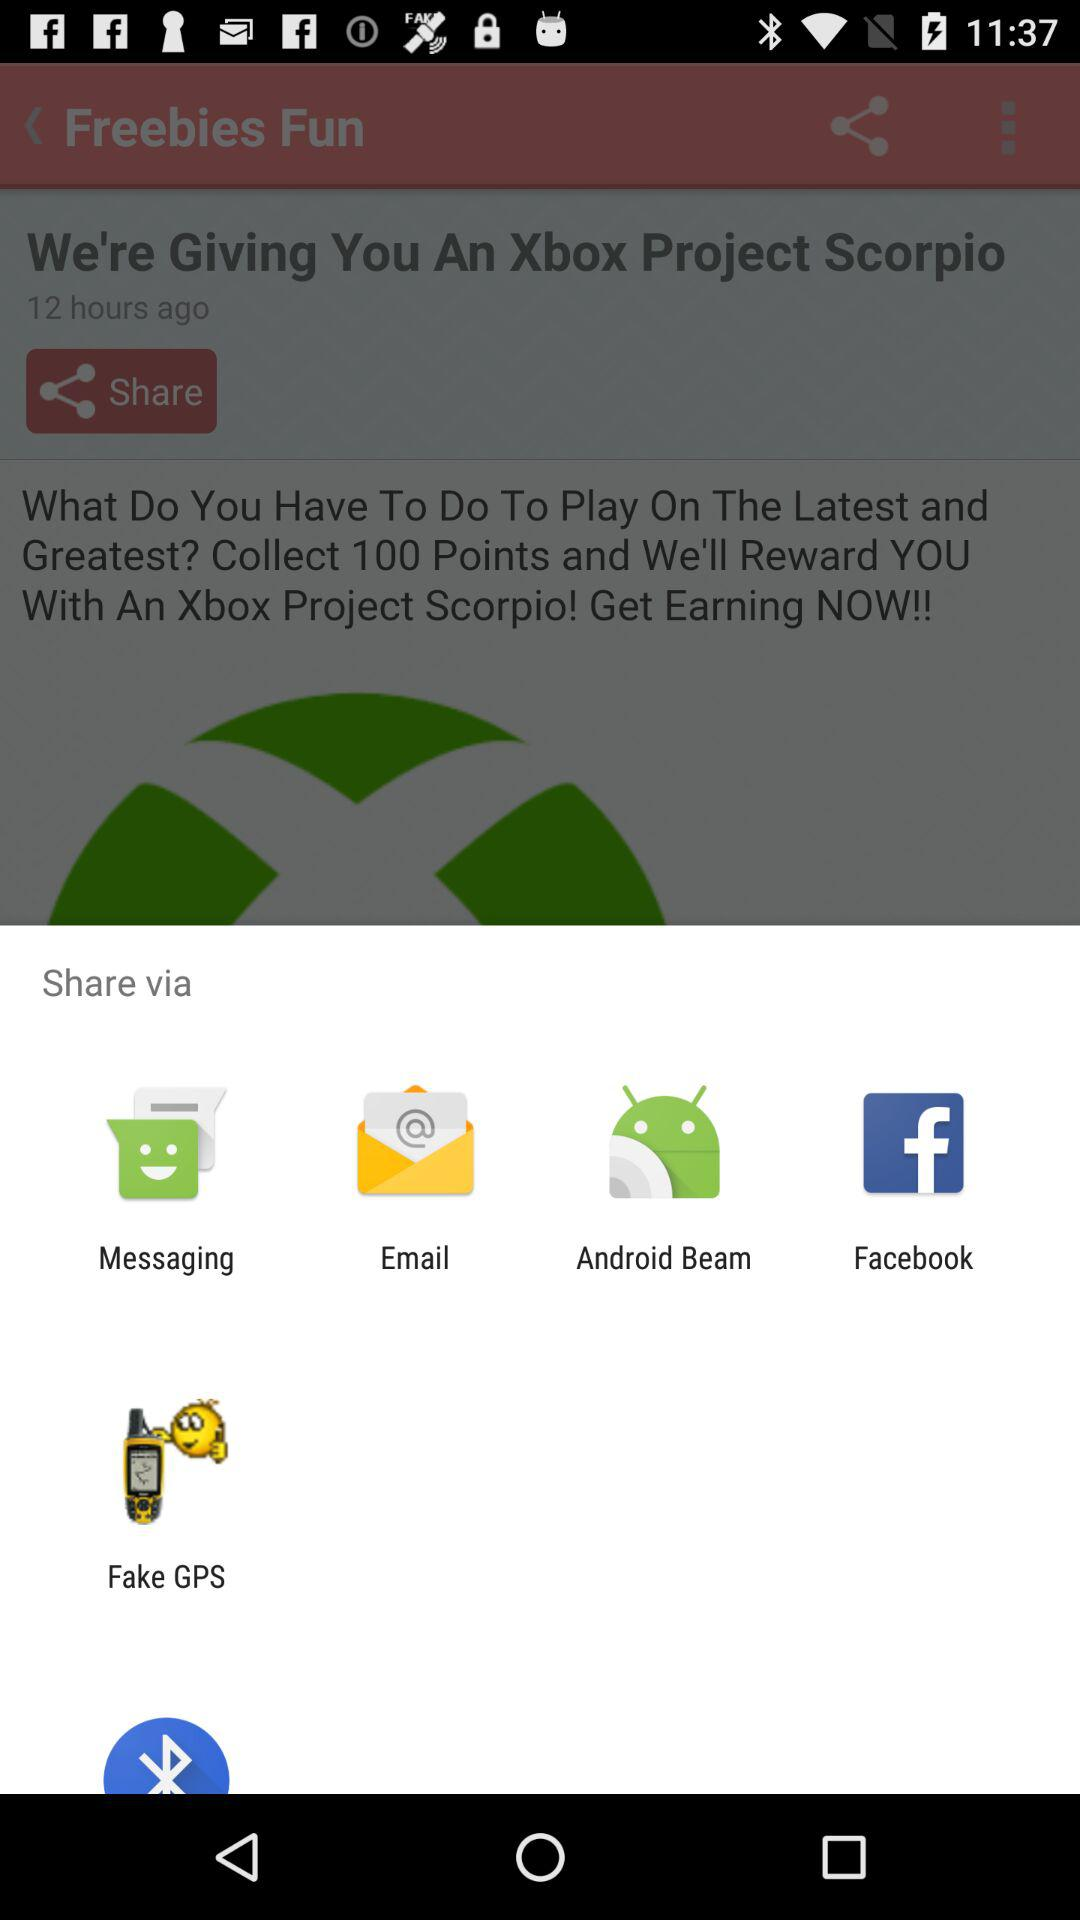What are the sharing options? The sharing options are "Messaging", "Email", "Android Beam", "Facebook" and "Fake GPS". 